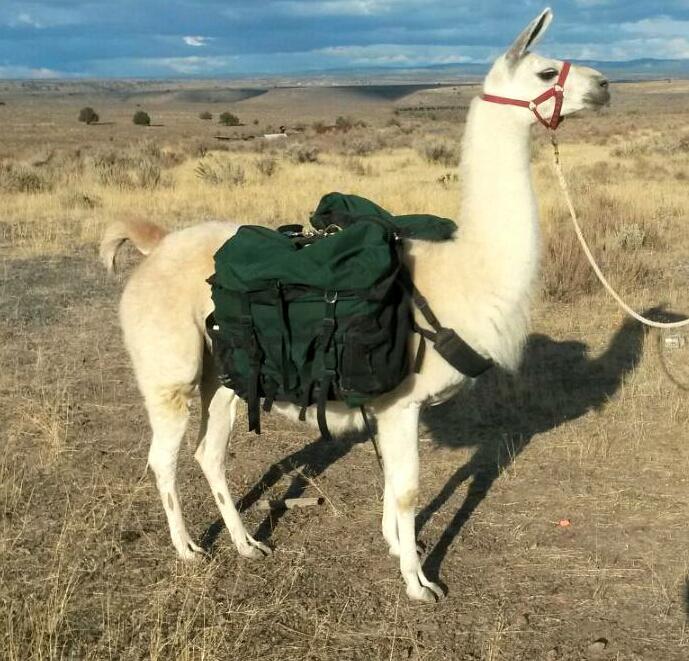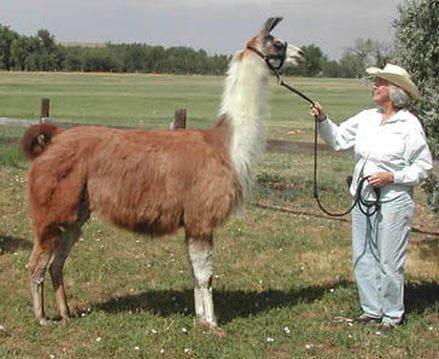The first image is the image on the left, the second image is the image on the right. Examine the images to the left and right. Is the description "Something is wearing pink." accurate? Answer yes or no. No. The first image is the image on the left, the second image is the image on the right. Evaluate the accuracy of this statement regarding the images: "At least one person can be seen holding reins.". Is it true? Answer yes or no. Yes. 